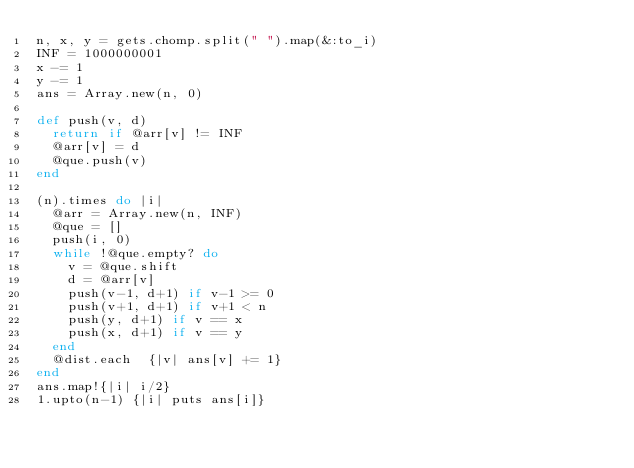<code> <loc_0><loc_0><loc_500><loc_500><_Ruby_>n, x, y = gets.chomp.split(" ").map(&:to_i)
INF = 1000000001
x -= 1
y -= 1
ans = Array.new(n, 0)
 
def push(v, d)
  return if @arr[v] != INF
  @arr[v] = d
  @que.push(v)
end
 
(n).times do |i|
  @arr = Array.new(n, INF)
  @que = []
  push(i, 0)
  while !@que.empty? do
    v = @que.shift
    d = @arr[v]
    push(v-1, d+1) if v-1 >= 0 
    push(v+1, d+1) if v+1 < n
    push(y, d+1) if v == x 
    push(x, d+1) if v == y 
  end
  @dist.each  {|v| ans[v] += 1}
end
ans.map!{|i| i/2}
1.upto(n-1) {|i| puts ans[i]}</code> 